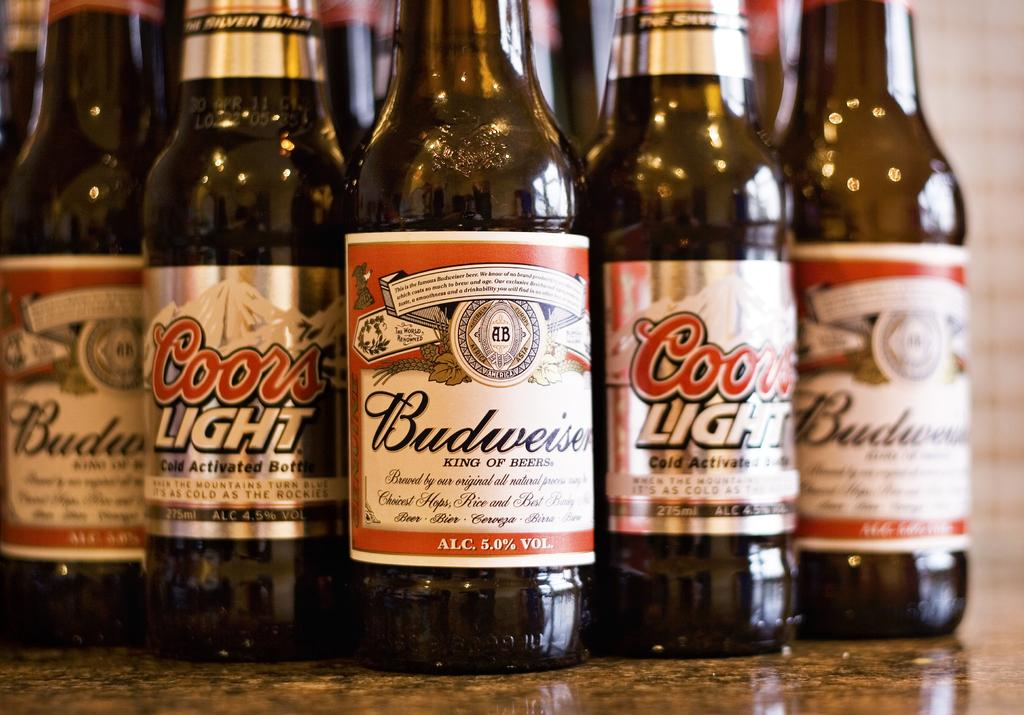<image>
Present a compact description of the photo's key features. Bottles of Budweiser and Coors Light are out on a marble counter. 